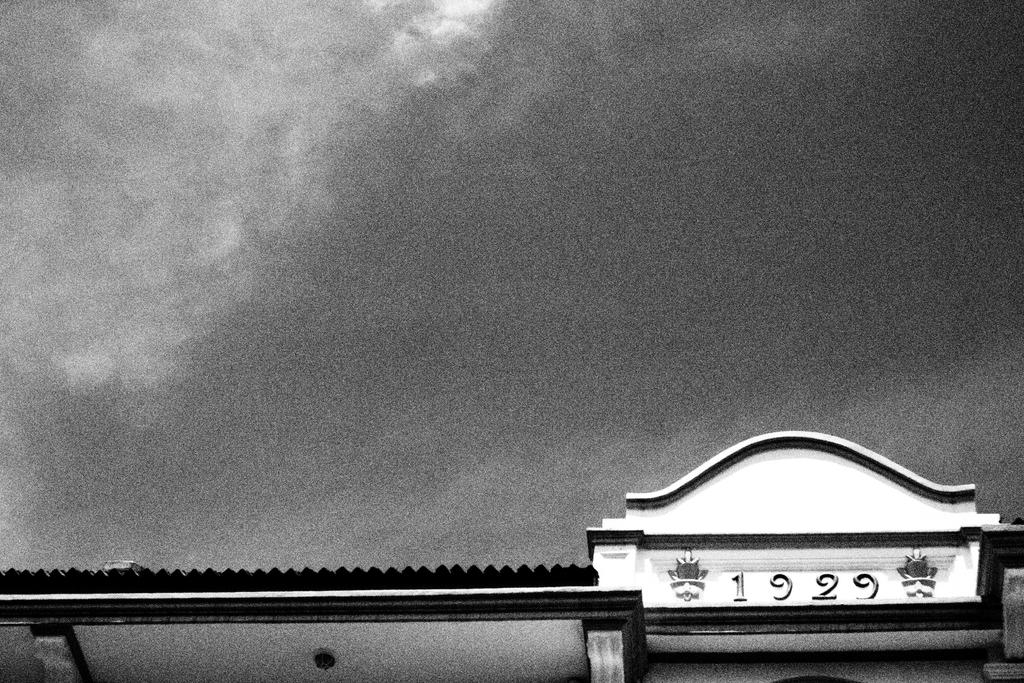What is the color scheme of the image? The image is black and white. What can be seen at the bottom of the image? There is a building at the bottom of the image. How many giants are visible in the image? There are no giants present in the image; it is a black and white image featuring a building at the bottom. 